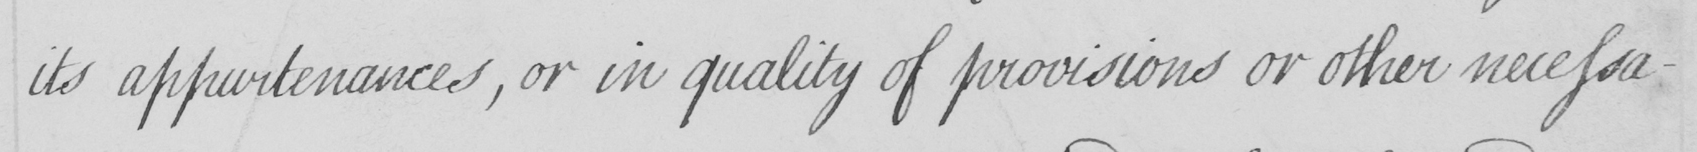What is written in this line of handwriting? its appurtenances , or in quality of provisions or other necessa- 